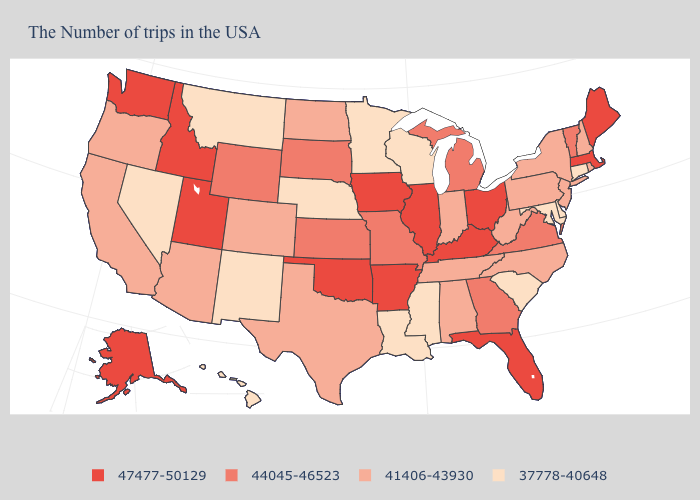What is the lowest value in states that border Utah?
Quick response, please. 37778-40648. Does Georgia have a lower value than Arkansas?
Give a very brief answer. Yes. What is the value of Colorado?
Be succinct. 41406-43930. Which states have the highest value in the USA?
Answer briefly. Maine, Massachusetts, Ohio, Florida, Kentucky, Illinois, Arkansas, Iowa, Oklahoma, Utah, Idaho, Washington, Alaska. Among the states that border Utah , does Colorado have the highest value?
Give a very brief answer. No. What is the highest value in states that border Florida?
Concise answer only. 44045-46523. Which states have the highest value in the USA?
Keep it brief. Maine, Massachusetts, Ohio, Florida, Kentucky, Illinois, Arkansas, Iowa, Oklahoma, Utah, Idaho, Washington, Alaska. What is the value of North Dakota?
Keep it brief. 41406-43930. What is the value of Vermont?
Short answer required. 44045-46523. Name the states that have a value in the range 47477-50129?
Keep it brief. Maine, Massachusetts, Ohio, Florida, Kentucky, Illinois, Arkansas, Iowa, Oklahoma, Utah, Idaho, Washington, Alaska. What is the highest value in the Northeast ?
Give a very brief answer. 47477-50129. What is the value of Arkansas?
Quick response, please. 47477-50129. Name the states that have a value in the range 47477-50129?
Quick response, please. Maine, Massachusetts, Ohio, Florida, Kentucky, Illinois, Arkansas, Iowa, Oklahoma, Utah, Idaho, Washington, Alaska. Does the first symbol in the legend represent the smallest category?
Quick response, please. No. Name the states that have a value in the range 41406-43930?
Write a very short answer. Rhode Island, New Hampshire, New York, New Jersey, Pennsylvania, North Carolina, West Virginia, Indiana, Alabama, Tennessee, Texas, North Dakota, Colorado, Arizona, California, Oregon. 